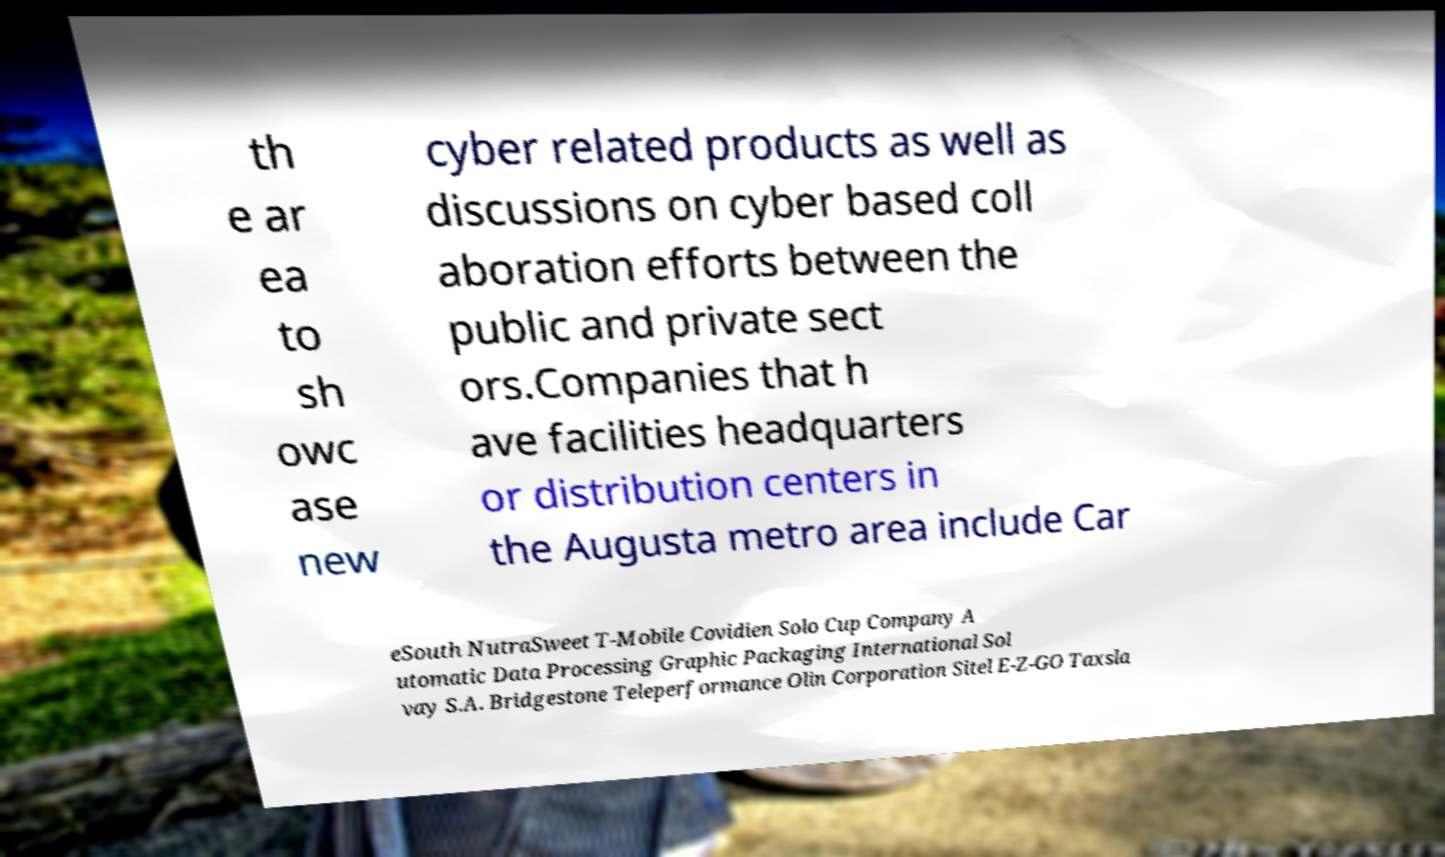There's text embedded in this image that I need extracted. Can you transcribe it verbatim? th e ar ea to sh owc ase new cyber related products as well as discussions on cyber based coll aboration efforts between the public and private sect ors.Companies that h ave facilities headquarters or distribution centers in the Augusta metro area include Car eSouth NutraSweet T-Mobile Covidien Solo Cup Company A utomatic Data Processing Graphic Packaging International Sol vay S.A. Bridgestone Teleperformance Olin Corporation Sitel E-Z-GO Taxsla 